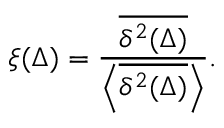<formula> <loc_0><loc_0><loc_500><loc_500>\xi ( \Delta ) = \frac { \overline { { \delta ^ { 2 } ( \Delta ) } } } { \left < \overline { { \delta ^ { 2 } ( \Delta ) } } \right > } .</formula> 